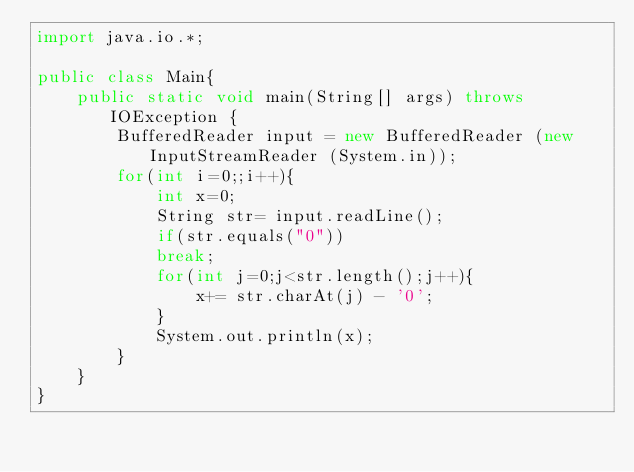Convert code to text. <code><loc_0><loc_0><loc_500><loc_500><_Java_>import java.io.*;
 
public class Main{
    public static void main(String[] args) throws IOException {
        BufferedReader input = new BufferedReader (new InputStreamReader (System.in));
        for(int i=0;;i++){
            int x=0;
            String str= input.readLine();
            if(str.equals("0"))
        	break;
            for(int j=0;j<str.length();j++){
                x+= str.charAt(j) - '0';
            }
            System.out.println(x);
        }
    }
}</code> 